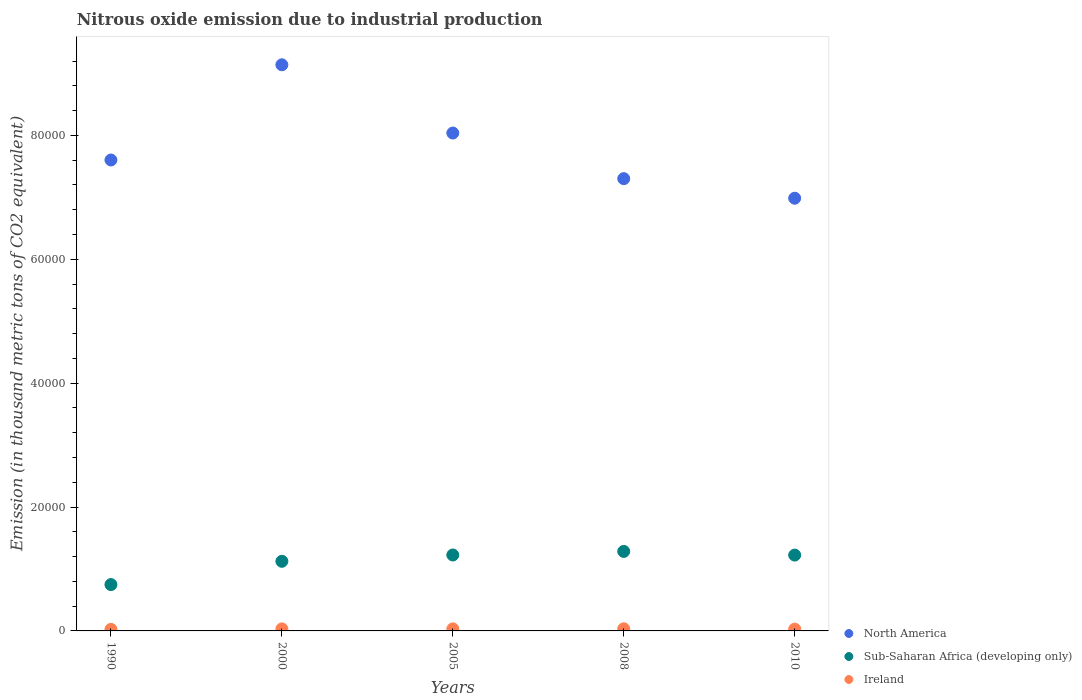Is the number of dotlines equal to the number of legend labels?
Your answer should be compact. Yes. What is the amount of nitrous oxide emitted in North America in 2008?
Provide a succinct answer. 7.30e+04. Across all years, what is the maximum amount of nitrous oxide emitted in Ireland?
Provide a succinct answer. 340.5. Across all years, what is the minimum amount of nitrous oxide emitted in Sub-Saharan Africa (developing only)?
Ensure brevity in your answer.  7482.3. In which year was the amount of nitrous oxide emitted in Ireland minimum?
Give a very brief answer. 1990. What is the total amount of nitrous oxide emitted in Ireland in the graph?
Your response must be concise. 1530.1. What is the difference between the amount of nitrous oxide emitted in Ireland in 1990 and that in 2000?
Make the answer very short. -79.9. What is the difference between the amount of nitrous oxide emitted in Ireland in 2005 and the amount of nitrous oxide emitted in Sub-Saharan Africa (developing only) in 2010?
Offer a terse response. -1.19e+04. What is the average amount of nitrous oxide emitted in Ireland per year?
Your answer should be very brief. 306.02. In the year 2010, what is the difference between the amount of nitrous oxide emitted in North America and amount of nitrous oxide emitted in Sub-Saharan Africa (developing only)?
Keep it short and to the point. 5.76e+04. What is the ratio of the amount of nitrous oxide emitted in Sub-Saharan Africa (developing only) in 2005 to that in 2010?
Offer a very short reply. 1. Is the amount of nitrous oxide emitted in North America in 2000 less than that in 2008?
Offer a terse response. No. Is the difference between the amount of nitrous oxide emitted in North America in 1990 and 2005 greater than the difference between the amount of nitrous oxide emitted in Sub-Saharan Africa (developing only) in 1990 and 2005?
Provide a short and direct response. Yes. What is the difference between the highest and the second highest amount of nitrous oxide emitted in North America?
Offer a very short reply. 1.10e+04. What is the difference between the highest and the lowest amount of nitrous oxide emitted in Sub-Saharan Africa (developing only)?
Your answer should be compact. 5351.1. In how many years, is the amount of nitrous oxide emitted in Ireland greater than the average amount of nitrous oxide emitted in Ireland taken over all years?
Make the answer very short. 3. Is the sum of the amount of nitrous oxide emitted in Sub-Saharan Africa (developing only) in 2005 and 2010 greater than the maximum amount of nitrous oxide emitted in Ireland across all years?
Your answer should be very brief. Yes. Is the amount of nitrous oxide emitted in Sub-Saharan Africa (developing only) strictly greater than the amount of nitrous oxide emitted in Ireland over the years?
Offer a terse response. Yes. Where does the legend appear in the graph?
Offer a very short reply. Bottom right. What is the title of the graph?
Ensure brevity in your answer.  Nitrous oxide emission due to industrial production. What is the label or title of the Y-axis?
Your response must be concise. Emission (in thousand metric tons of CO2 equivalent). What is the Emission (in thousand metric tons of CO2 equivalent) in North America in 1990?
Provide a short and direct response. 7.60e+04. What is the Emission (in thousand metric tons of CO2 equivalent) of Sub-Saharan Africa (developing only) in 1990?
Provide a succinct answer. 7482.3. What is the Emission (in thousand metric tons of CO2 equivalent) of Ireland in 1990?
Your answer should be very brief. 246.7. What is the Emission (in thousand metric tons of CO2 equivalent) of North America in 2000?
Provide a short and direct response. 9.14e+04. What is the Emission (in thousand metric tons of CO2 equivalent) of Sub-Saharan Africa (developing only) in 2000?
Your answer should be very brief. 1.12e+04. What is the Emission (in thousand metric tons of CO2 equivalent) of Ireland in 2000?
Make the answer very short. 326.6. What is the Emission (in thousand metric tons of CO2 equivalent) in North America in 2005?
Your response must be concise. 8.04e+04. What is the Emission (in thousand metric tons of CO2 equivalent) of Sub-Saharan Africa (developing only) in 2005?
Provide a succinct answer. 1.23e+04. What is the Emission (in thousand metric tons of CO2 equivalent) in Ireland in 2005?
Provide a short and direct response. 331.1. What is the Emission (in thousand metric tons of CO2 equivalent) in North America in 2008?
Provide a short and direct response. 7.30e+04. What is the Emission (in thousand metric tons of CO2 equivalent) of Sub-Saharan Africa (developing only) in 2008?
Your answer should be compact. 1.28e+04. What is the Emission (in thousand metric tons of CO2 equivalent) of Ireland in 2008?
Provide a short and direct response. 340.5. What is the Emission (in thousand metric tons of CO2 equivalent) of North America in 2010?
Offer a terse response. 6.99e+04. What is the Emission (in thousand metric tons of CO2 equivalent) of Sub-Saharan Africa (developing only) in 2010?
Offer a terse response. 1.22e+04. What is the Emission (in thousand metric tons of CO2 equivalent) of Ireland in 2010?
Offer a very short reply. 285.2. Across all years, what is the maximum Emission (in thousand metric tons of CO2 equivalent) of North America?
Provide a succinct answer. 9.14e+04. Across all years, what is the maximum Emission (in thousand metric tons of CO2 equivalent) in Sub-Saharan Africa (developing only)?
Keep it short and to the point. 1.28e+04. Across all years, what is the maximum Emission (in thousand metric tons of CO2 equivalent) of Ireland?
Your answer should be compact. 340.5. Across all years, what is the minimum Emission (in thousand metric tons of CO2 equivalent) in North America?
Your answer should be very brief. 6.99e+04. Across all years, what is the minimum Emission (in thousand metric tons of CO2 equivalent) in Sub-Saharan Africa (developing only)?
Provide a short and direct response. 7482.3. Across all years, what is the minimum Emission (in thousand metric tons of CO2 equivalent) in Ireland?
Offer a terse response. 246.7. What is the total Emission (in thousand metric tons of CO2 equivalent) of North America in the graph?
Your answer should be compact. 3.91e+05. What is the total Emission (in thousand metric tons of CO2 equivalent) in Sub-Saharan Africa (developing only) in the graph?
Provide a short and direct response. 5.61e+04. What is the total Emission (in thousand metric tons of CO2 equivalent) in Ireland in the graph?
Provide a succinct answer. 1530.1. What is the difference between the Emission (in thousand metric tons of CO2 equivalent) in North America in 1990 and that in 2000?
Your answer should be compact. -1.54e+04. What is the difference between the Emission (in thousand metric tons of CO2 equivalent) in Sub-Saharan Africa (developing only) in 1990 and that in 2000?
Your response must be concise. -3756.4. What is the difference between the Emission (in thousand metric tons of CO2 equivalent) in Ireland in 1990 and that in 2000?
Your answer should be very brief. -79.9. What is the difference between the Emission (in thousand metric tons of CO2 equivalent) of North America in 1990 and that in 2005?
Your response must be concise. -4350.1. What is the difference between the Emission (in thousand metric tons of CO2 equivalent) of Sub-Saharan Africa (developing only) in 1990 and that in 2005?
Keep it short and to the point. -4774.5. What is the difference between the Emission (in thousand metric tons of CO2 equivalent) in Ireland in 1990 and that in 2005?
Provide a short and direct response. -84.4. What is the difference between the Emission (in thousand metric tons of CO2 equivalent) in North America in 1990 and that in 2008?
Make the answer very short. 3012.9. What is the difference between the Emission (in thousand metric tons of CO2 equivalent) of Sub-Saharan Africa (developing only) in 1990 and that in 2008?
Ensure brevity in your answer.  -5351.1. What is the difference between the Emission (in thousand metric tons of CO2 equivalent) in Ireland in 1990 and that in 2008?
Your response must be concise. -93.8. What is the difference between the Emission (in thousand metric tons of CO2 equivalent) of North America in 1990 and that in 2010?
Make the answer very short. 6173. What is the difference between the Emission (in thousand metric tons of CO2 equivalent) in Sub-Saharan Africa (developing only) in 1990 and that in 2010?
Ensure brevity in your answer.  -4759.9. What is the difference between the Emission (in thousand metric tons of CO2 equivalent) in Ireland in 1990 and that in 2010?
Provide a succinct answer. -38.5. What is the difference between the Emission (in thousand metric tons of CO2 equivalent) in North America in 2000 and that in 2005?
Ensure brevity in your answer.  1.10e+04. What is the difference between the Emission (in thousand metric tons of CO2 equivalent) in Sub-Saharan Africa (developing only) in 2000 and that in 2005?
Give a very brief answer. -1018.1. What is the difference between the Emission (in thousand metric tons of CO2 equivalent) in North America in 2000 and that in 2008?
Keep it short and to the point. 1.84e+04. What is the difference between the Emission (in thousand metric tons of CO2 equivalent) in Sub-Saharan Africa (developing only) in 2000 and that in 2008?
Keep it short and to the point. -1594.7. What is the difference between the Emission (in thousand metric tons of CO2 equivalent) in North America in 2000 and that in 2010?
Your response must be concise. 2.15e+04. What is the difference between the Emission (in thousand metric tons of CO2 equivalent) of Sub-Saharan Africa (developing only) in 2000 and that in 2010?
Your answer should be very brief. -1003.5. What is the difference between the Emission (in thousand metric tons of CO2 equivalent) of Ireland in 2000 and that in 2010?
Give a very brief answer. 41.4. What is the difference between the Emission (in thousand metric tons of CO2 equivalent) in North America in 2005 and that in 2008?
Offer a terse response. 7363. What is the difference between the Emission (in thousand metric tons of CO2 equivalent) of Sub-Saharan Africa (developing only) in 2005 and that in 2008?
Make the answer very short. -576.6. What is the difference between the Emission (in thousand metric tons of CO2 equivalent) of North America in 2005 and that in 2010?
Your response must be concise. 1.05e+04. What is the difference between the Emission (in thousand metric tons of CO2 equivalent) of Sub-Saharan Africa (developing only) in 2005 and that in 2010?
Provide a short and direct response. 14.6. What is the difference between the Emission (in thousand metric tons of CO2 equivalent) in Ireland in 2005 and that in 2010?
Make the answer very short. 45.9. What is the difference between the Emission (in thousand metric tons of CO2 equivalent) in North America in 2008 and that in 2010?
Give a very brief answer. 3160.1. What is the difference between the Emission (in thousand metric tons of CO2 equivalent) in Sub-Saharan Africa (developing only) in 2008 and that in 2010?
Make the answer very short. 591.2. What is the difference between the Emission (in thousand metric tons of CO2 equivalent) in Ireland in 2008 and that in 2010?
Offer a very short reply. 55.3. What is the difference between the Emission (in thousand metric tons of CO2 equivalent) of North America in 1990 and the Emission (in thousand metric tons of CO2 equivalent) of Sub-Saharan Africa (developing only) in 2000?
Make the answer very short. 6.48e+04. What is the difference between the Emission (in thousand metric tons of CO2 equivalent) in North America in 1990 and the Emission (in thousand metric tons of CO2 equivalent) in Ireland in 2000?
Your answer should be very brief. 7.57e+04. What is the difference between the Emission (in thousand metric tons of CO2 equivalent) in Sub-Saharan Africa (developing only) in 1990 and the Emission (in thousand metric tons of CO2 equivalent) in Ireland in 2000?
Offer a terse response. 7155.7. What is the difference between the Emission (in thousand metric tons of CO2 equivalent) in North America in 1990 and the Emission (in thousand metric tons of CO2 equivalent) in Sub-Saharan Africa (developing only) in 2005?
Your answer should be very brief. 6.38e+04. What is the difference between the Emission (in thousand metric tons of CO2 equivalent) of North America in 1990 and the Emission (in thousand metric tons of CO2 equivalent) of Ireland in 2005?
Your response must be concise. 7.57e+04. What is the difference between the Emission (in thousand metric tons of CO2 equivalent) in Sub-Saharan Africa (developing only) in 1990 and the Emission (in thousand metric tons of CO2 equivalent) in Ireland in 2005?
Offer a very short reply. 7151.2. What is the difference between the Emission (in thousand metric tons of CO2 equivalent) of North America in 1990 and the Emission (in thousand metric tons of CO2 equivalent) of Sub-Saharan Africa (developing only) in 2008?
Offer a very short reply. 6.32e+04. What is the difference between the Emission (in thousand metric tons of CO2 equivalent) of North America in 1990 and the Emission (in thousand metric tons of CO2 equivalent) of Ireland in 2008?
Offer a terse response. 7.57e+04. What is the difference between the Emission (in thousand metric tons of CO2 equivalent) in Sub-Saharan Africa (developing only) in 1990 and the Emission (in thousand metric tons of CO2 equivalent) in Ireland in 2008?
Offer a terse response. 7141.8. What is the difference between the Emission (in thousand metric tons of CO2 equivalent) in North America in 1990 and the Emission (in thousand metric tons of CO2 equivalent) in Sub-Saharan Africa (developing only) in 2010?
Your response must be concise. 6.38e+04. What is the difference between the Emission (in thousand metric tons of CO2 equivalent) in North America in 1990 and the Emission (in thousand metric tons of CO2 equivalent) in Ireland in 2010?
Keep it short and to the point. 7.57e+04. What is the difference between the Emission (in thousand metric tons of CO2 equivalent) in Sub-Saharan Africa (developing only) in 1990 and the Emission (in thousand metric tons of CO2 equivalent) in Ireland in 2010?
Your response must be concise. 7197.1. What is the difference between the Emission (in thousand metric tons of CO2 equivalent) of North America in 2000 and the Emission (in thousand metric tons of CO2 equivalent) of Sub-Saharan Africa (developing only) in 2005?
Offer a terse response. 7.91e+04. What is the difference between the Emission (in thousand metric tons of CO2 equivalent) of North America in 2000 and the Emission (in thousand metric tons of CO2 equivalent) of Ireland in 2005?
Provide a short and direct response. 9.11e+04. What is the difference between the Emission (in thousand metric tons of CO2 equivalent) of Sub-Saharan Africa (developing only) in 2000 and the Emission (in thousand metric tons of CO2 equivalent) of Ireland in 2005?
Your answer should be compact. 1.09e+04. What is the difference between the Emission (in thousand metric tons of CO2 equivalent) in North America in 2000 and the Emission (in thousand metric tons of CO2 equivalent) in Sub-Saharan Africa (developing only) in 2008?
Your answer should be compact. 7.86e+04. What is the difference between the Emission (in thousand metric tons of CO2 equivalent) in North America in 2000 and the Emission (in thousand metric tons of CO2 equivalent) in Ireland in 2008?
Give a very brief answer. 9.10e+04. What is the difference between the Emission (in thousand metric tons of CO2 equivalent) in Sub-Saharan Africa (developing only) in 2000 and the Emission (in thousand metric tons of CO2 equivalent) in Ireland in 2008?
Ensure brevity in your answer.  1.09e+04. What is the difference between the Emission (in thousand metric tons of CO2 equivalent) in North America in 2000 and the Emission (in thousand metric tons of CO2 equivalent) in Sub-Saharan Africa (developing only) in 2010?
Give a very brief answer. 7.91e+04. What is the difference between the Emission (in thousand metric tons of CO2 equivalent) of North America in 2000 and the Emission (in thousand metric tons of CO2 equivalent) of Ireland in 2010?
Make the answer very short. 9.11e+04. What is the difference between the Emission (in thousand metric tons of CO2 equivalent) in Sub-Saharan Africa (developing only) in 2000 and the Emission (in thousand metric tons of CO2 equivalent) in Ireland in 2010?
Your answer should be very brief. 1.10e+04. What is the difference between the Emission (in thousand metric tons of CO2 equivalent) of North America in 2005 and the Emission (in thousand metric tons of CO2 equivalent) of Sub-Saharan Africa (developing only) in 2008?
Keep it short and to the point. 6.75e+04. What is the difference between the Emission (in thousand metric tons of CO2 equivalent) in North America in 2005 and the Emission (in thousand metric tons of CO2 equivalent) in Ireland in 2008?
Keep it short and to the point. 8.00e+04. What is the difference between the Emission (in thousand metric tons of CO2 equivalent) of Sub-Saharan Africa (developing only) in 2005 and the Emission (in thousand metric tons of CO2 equivalent) of Ireland in 2008?
Your answer should be compact. 1.19e+04. What is the difference between the Emission (in thousand metric tons of CO2 equivalent) of North America in 2005 and the Emission (in thousand metric tons of CO2 equivalent) of Sub-Saharan Africa (developing only) in 2010?
Provide a short and direct response. 6.81e+04. What is the difference between the Emission (in thousand metric tons of CO2 equivalent) in North America in 2005 and the Emission (in thousand metric tons of CO2 equivalent) in Ireland in 2010?
Keep it short and to the point. 8.01e+04. What is the difference between the Emission (in thousand metric tons of CO2 equivalent) in Sub-Saharan Africa (developing only) in 2005 and the Emission (in thousand metric tons of CO2 equivalent) in Ireland in 2010?
Your answer should be compact. 1.20e+04. What is the difference between the Emission (in thousand metric tons of CO2 equivalent) of North America in 2008 and the Emission (in thousand metric tons of CO2 equivalent) of Sub-Saharan Africa (developing only) in 2010?
Make the answer very short. 6.08e+04. What is the difference between the Emission (in thousand metric tons of CO2 equivalent) of North America in 2008 and the Emission (in thousand metric tons of CO2 equivalent) of Ireland in 2010?
Keep it short and to the point. 7.27e+04. What is the difference between the Emission (in thousand metric tons of CO2 equivalent) of Sub-Saharan Africa (developing only) in 2008 and the Emission (in thousand metric tons of CO2 equivalent) of Ireland in 2010?
Give a very brief answer. 1.25e+04. What is the average Emission (in thousand metric tons of CO2 equivalent) of North America per year?
Make the answer very short. 7.81e+04. What is the average Emission (in thousand metric tons of CO2 equivalent) of Sub-Saharan Africa (developing only) per year?
Provide a short and direct response. 1.12e+04. What is the average Emission (in thousand metric tons of CO2 equivalent) of Ireland per year?
Ensure brevity in your answer.  306.02. In the year 1990, what is the difference between the Emission (in thousand metric tons of CO2 equivalent) of North America and Emission (in thousand metric tons of CO2 equivalent) of Sub-Saharan Africa (developing only)?
Ensure brevity in your answer.  6.85e+04. In the year 1990, what is the difference between the Emission (in thousand metric tons of CO2 equivalent) in North America and Emission (in thousand metric tons of CO2 equivalent) in Ireland?
Your answer should be very brief. 7.58e+04. In the year 1990, what is the difference between the Emission (in thousand metric tons of CO2 equivalent) in Sub-Saharan Africa (developing only) and Emission (in thousand metric tons of CO2 equivalent) in Ireland?
Give a very brief answer. 7235.6. In the year 2000, what is the difference between the Emission (in thousand metric tons of CO2 equivalent) in North America and Emission (in thousand metric tons of CO2 equivalent) in Sub-Saharan Africa (developing only)?
Provide a short and direct response. 8.01e+04. In the year 2000, what is the difference between the Emission (in thousand metric tons of CO2 equivalent) in North America and Emission (in thousand metric tons of CO2 equivalent) in Ireland?
Ensure brevity in your answer.  9.11e+04. In the year 2000, what is the difference between the Emission (in thousand metric tons of CO2 equivalent) of Sub-Saharan Africa (developing only) and Emission (in thousand metric tons of CO2 equivalent) of Ireland?
Offer a terse response. 1.09e+04. In the year 2005, what is the difference between the Emission (in thousand metric tons of CO2 equivalent) of North America and Emission (in thousand metric tons of CO2 equivalent) of Sub-Saharan Africa (developing only)?
Your answer should be compact. 6.81e+04. In the year 2005, what is the difference between the Emission (in thousand metric tons of CO2 equivalent) in North America and Emission (in thousand metric tons of CO2 equivalent) in Ireland?
Your answer should be very brief. 8.00e+04. In the year 2005, what is the difference between the Emission (in thousand metric tons of CO2 equivalent) in Sub-Saharan Africa (developing only) and Emission (in thousand metric tons of CO2 equivalent) in Ireland?
Give a very brief answer. 1.19e+04. In the year 2008, what is the difference between the Emission (in thousand metric tons of CO2 equivalent) of North America and Emission (in thousand metric tons of CO2 equivalent) of Sub-Saharan Africa (developing only)?
Make the answer very short. 6.02e+04. In the year 2008, what is the difference between the Emission (in thousand metric tons of CO2 equivalent) of North America and Emission (in thousand metric tons of CO2 equivalent) of Ireland?
Offer a terse response. 7.27e+04. In the year 2008, what is the difference between the Emission (in thousand metric tons of CO2 equivalent) of Sub-Saharan Africa (developing only) and Emission (in thousand metric tons of CO2 equivalent) of Ireland?
Give a very brief answer. 1.25e+04. In the year 2010, what is the difference between the Emission (in thousand metric tons of CO2 equivalent) in North America and Emission (in thousand metric tons of CO2 equivalent) in Sub-Saharan Africa (developing only)?
Provide a succinct answer. 5.76e+04. In the year 2010, what is the difference between the Emission (in thousand metric tons of CO2 equivalent) in North America and Emission (in thousand metric tons of CO2 equivalent) in Ireland?
Offer a very short reply. 6.96e+04. In the year 2010, what is the difference between the Emission (in thousand metric tons of CO2 equivalent) in Sub-Saharan Africa (developing only) and Emission (in thousand metric tons of CO2 equivalent) in Ireland?
Keep it short and to the point. 1.20e+04. What is the ratio of the Emission (in thousand metric tons of CO2 equivalent) of North America in 1990 to that in 2000?
Your answer should be compact. 0.83. What is the ratio of the Emission (in thousand metric tons of CO2 equivalent) in Sub-Saharan Africa (developing only) in 1990 to that in 2000?
Your answer should be very brief. 0.67. What is the ratio of the Emission (in thousand metric tons of CO2 equivalent) in Ireland in 1990 to that in 2000?
Provide a short and direct response. 0.76. What is the ratio of the Emission (in thousand metric tons of CO2 equivalent) in North America in 1990 to that in 2005?
Offer a terse response. 0.95. What is the ratio of the Emission (in thousand metric tons of CO2 equivalent) in Sub-Saharan Africa (developing only) in 1990 to that in 2005?
Provide a short and direct response. 0.61. What is the ratio of the Emission (in thousand metric tons of CO2 equivalent) in Ireland in 1990 to that in 2005?
Keep it short and to the point. 0.75. What is the ratio of the Emission (in thousand metric tons of CO2 equivalent) in North America in 1990 to that in 2008?
Give a very brief answer. 1.04. What is the ratio of the Emission (in thousand metric tons of CO2 equivalent) in Sub-Saharan Africa (developing only) in 1990 to that in 2008?
Make the answer very short. 0.58. What is the ratio of the Emission (in thousand metric tons of CO2 equivalent) in Ireland in 1990 to that in 2008?
Your response must be concise. 0.72. What is the ratio of the Emission (in thousand metric tons of CO2 equivalent) of North America in 1990 to that in 2010?
Give a very brief answer. 1.09. What is the ratio of the Emission (in thousand metric tons of CO2 equivalent) in Sub-Saharan Africa (developing only) in 1990 to that in 2010?
Your answer should be very brief. 0.61. What is the ratio of the Emission (in thousand metric tons of CO2 equivalent) in Ireland in 1990 to that in 2010?
Ensure brevity in your answer.  0.86. What is the ratio of the Emission (in thousand metric tons of CO2 equivalent) in North America in 2000 to that in 2005?
Offer a terse response. 1.14. What is the ratio of the Emission (in thousand metric tons of CO2 equivalent) in Sub-Saharan Africa (developing only) in 2000 to that in 2005?
Provide a short and direct response. 0.92. What is the ratio of the Emission (in thousand metric tons of CO2 equivalent) in Ireland in 2000 to that in 2005?
Your answer should be compact. 0.99. What is the ratio of the Emission (in thousand metric tons of CO2 equivalent) in North America in 2000 to that in 2008?
Your response must be concise. 1.25. What is the ratio of the Emission (in thousand metric tons of CO2 equivalent) in Sub-Saharan Africa (developing only) in 2000 to that in 2008?
Make the answer very short. 0.88. What is the ratio of the Emission (in thousand metric tons of CO2 equivalent) in Ireland in 2000 to that in 2008?
Keep it short and to the point. 0.96. What is the ratio of the Emission (in thousand metric tons of CO2 equivalent) of North America in 2000 to that in 2010?
Keep it short and to the point. 1.31. What is the ratio of the Emission (in thousand metric tons of CO2 equivalent) of Sub-Saharan Africa (developing only) in 2000 to that in 2010?
Provide a short and direct response. 0.92. What is the ratio of the Emission (in thousand metric tons of CO2 equivalent) of Ireland in 2000 to that in 2010?
Ensure brevity in your answer.  1.15. What is the ratio of the Emission (in thousand metric tons of CO2 equivalent) of North America in 2005 to that in 2008?
Make the answer very short. 1.1. What is the ratio of the Emission (in thousand metric tons of CO2 equivalent) of Sub-Saharan Africa (developing only) in 2005 to that in 2008?
Your answer should be very brief. 0.96. What is the ratio of the Emission (in thousand metric tons of CO2 equivalent) of Ireland in 2005 to that in 2008?
Provide a succinct answer. 0.97. What is the ratio of the Emission (in thousand metric tons of CO2 equivalent) in North America in 2005 to that in 2010?
Ensure brevity in your answer.  1.15. What is the ratio of the Emission (in thousand metric tons of CO2 equivalent) in Ireland in 2005 to that in 2010?
Provide a short and direct response. 1.16. What is the ratio of the Emission (in thousand metric tons of CO2 equivalent) in North America in 2008 to that in 2010?
Ensure brevity in your answer.  1.05. What is the ratio of the Emission (in thousand metric tons of CO2 equivalent) of Sub-Saharan Africa (developing only) in 2008 to that in 2010?
Give a very brief answer. 1.05. What is the ratio of the Emission (in thousand metric tons of CO2 equivalent) in Ireland in 2008 to that in 2010?
Your answer should be very brief. 1.19. What is the difference between the highest and the second highest Emission (in thousand metric tons of CO2 equivalent) of North America?
Ensure brevity in your answer.  1.10e+04. What is the difference between the highest and the second highest Emission (in thousand metric tons of CO2 equivalent) of Sub-Saharan Africa (developing only)?
Provide a succinct answer. 576.6. What is the difference between the highest and the second highest Emission (in thousand metric tons of CO2 equivalent) of Ireland?
Provide a short and direct response. 9.4. What is the difference between the highest and the lowest Emission (in thousand metric tons of CO2 equivalent) of North America?
Ensure brevity in your answer.  2.15e+04. What is the difference between the highest and the lowest Emission (in thousand metric tons of CO2 equivalent) of Sub-Saharan Africa (developing only)?
Your answer should be compact. 5351.1. What is the difference between the highest and the lowest Emission (in thousand metric tons of CO2 equivalent) of Ireland?
Provide a succinct answer. 93.8. 